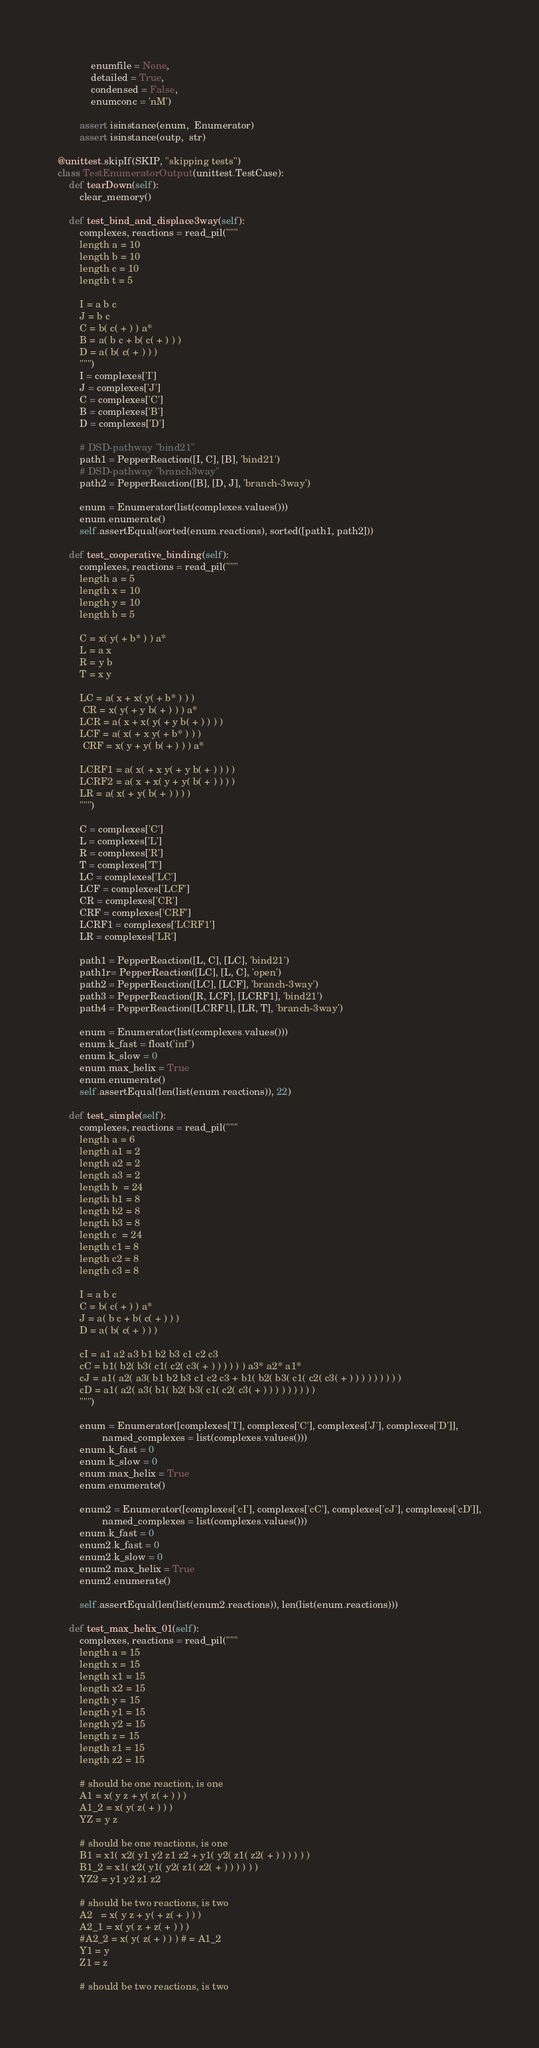Convert code to text. <code><loc_0><loc_0><loc_500><loc_500><_Python_>            enumfile = None,
            detailed = True, 
            condensed = False, 
            enumconc = 'nM')

        assert isinstance(enum,  Enumerator)
        assert isinstance(outp,  str)

@unittest.skipIf(SKIP, "skipping tests")
class TestEnumeratorOutput(unittest.TestCase):
    def tearDown(self):
        clear_memory()

    def test_bind_and_displace3way(self):
        complexes, reactions = read_pil("""
        length a = 10
        length b = 10
        length c = 10
        length t = 5

        I = a b c
        J = b c
        C = b( c( + ) ) a*
        B = a( b c + b( c( + ) ) )
        D = a( b( c( + ) ) )
        """)
        I = complexes['I']
        J = complexes['J']
        C = complexes['C']
        B = complexes['B']
        D = complexes['D']

        # DSD-pathway "bind21"
        path1 = PepperReaction([I, C], [B], 'bind21')
        # DSD-pathway "branch3way"
        path2 = PepperReaction([B], [D, J], 'branch-3way')

        enum = Enumerator(list(complexes.values()))
        enum.enumerate()
        self.assertEqual(sorted(enum.reactions), sorted([path1, path2]))

    def test_cooperative_binding(self):
        complexes, reactions = read_pil("""
        length a = 5
        length x = 10
        length y = 10
        length b = 5

        C = x( y( + b* ) ) a*
        L = a x
        R = y b
        T = x y

        LC = a( x + x( y( + b* ) ) )
         CR = x( y( + y b( + ) ) ) a*
        LCR = a( x + x( y( + y b( + ) ) ) )
        LCF = a( x( + x y( + b* ) ) )
         CRF = x( y + y( b( + ) ) ) a*

        LCRF1 = a( x( + x y( + y b( + ) ) ) )
        LCRF2 = a( x + x( y + y( b( + ) ) ) )
        LR = a( x( + y( b( + ) ) ) )
        """)

        C = complexes['C']
        L = complexes['L']
        R = complexes['R']
        T = complexes['T']
        LC = complexes['LC']
        LCF = complexes['LCF']
        CR = complexes['CR']
        CRF = complexes['CRF']
        LCRF1 = complexes['LCRF1']
        LR = complexes['LR']
        
        path1 = PepperReaction([L, C], [LC], 'bind21')
        path1r= PepperReaction([LC], [L, C], 'open')
        path2 = PepperReaction([LC], [LCF], 'branch-3way')
        path3 = PepperReaction([R, LCF], [LCRF1], 'bind21')
        path4 = PepperReaction([LCRF1], [LR, T], 'branch-3way')

        enum = Enumerator(list(complexes.values()))
        enum.k_fast = float('inf')
        enum.k_slow = 0
        enum.max_helix = True
        enum.enumerate()
        self.assertEqual(len(list(enum.reactions)), 22)

    def test_simple(self):
        complexes, reactions = read_pil("""
        length a = 6
        length a1 = 2
        length a2 = 2
        length a3 = 2
        length b  = 24
        length b1 = 8
        length b2 = 8
        length b3 = 8
        length c  = 24
        length c1 = 8
        length c2 = 8
        length c3 = 8

        I = a b c
        C = b( c( + ) ) a*
        J = a( b c + b( c( + ) ) )
        D = a( b( c( + ) ) )

        cI = a1 a2 a3 b1 b2 b3 c1 c2 c3
        cC = b1( b2( b3( c1( c2( c3( + ) ) ) ) ) ) a3* a2* a1*
        cJ = a1( a2( a3( b1 b2 b3 c1 c2 c3 + b1( b2( b3( c1( c2( c3( + ) ) ) ) ) ) ) ) )
        cD = a1( a2( a3( b1( b2( b3( c1( c2( c3( + ) ) ) ) ) ) ) ) )
        """)

        enum = Enumerator([complexes['I'], complexes['C'], complexes['J'], complexes['D']],
                named_complexes = list(complexes.values()))
        enum.k_fast = 0
        enum.k_slow = 0
        enum.max_helix = True
        enum.enumerate()

        enum2 = Enumerator([complexes['cI'], complexes['cC'], complexes['cJ'], complexes['cD']],
                named_complexes = list(complexes.values()))
        enum.k_fast = 0
        enum2.k_fast = 0
        enum2.k_slow = 0
        enum2.max_helix = True
        enum2.enumerate()

        self.assertEqual(len(list(enum2.reactions)), len(list(enum.reactions)))

    def test_max_helix_01(self):
        complexes, reactions = read_pil("""
        length a = 15
        length x = 15
        length x1 = 15
        length x2 = 15
        length y = 15
        length y1 = 15
        length y2 = 15
        length z = 15
        length z1 = 15
        length z2 = 15

        # should be one reaction, is one
        A1 = x( y z + y( z( + ) ) )
        A1_2 = x( y( z( + ) ) )
        YZ = y z

        # should be one reactions, is one
        B1 = x1( x2( y1 y2 z1 z2 + y1( y2( z1( z2( + ) ) ) ) ) ) 
        B1_2 = x1( x2( y1( y2( z1( z2( + ) ) ) ) ) ) 
        YZ2 = y1 y2 z1 z2

        # should be two reactions, is two
        A2   = x( y z + y( + z( + ) ) )
        A2_1 = x( y( z + z( + ) ) )
        #A2_2 = x( y( z( + ) ) ) # = A1_2
        Y1 = y
        Z1 = z

        # should be two reactions, is two</code> 